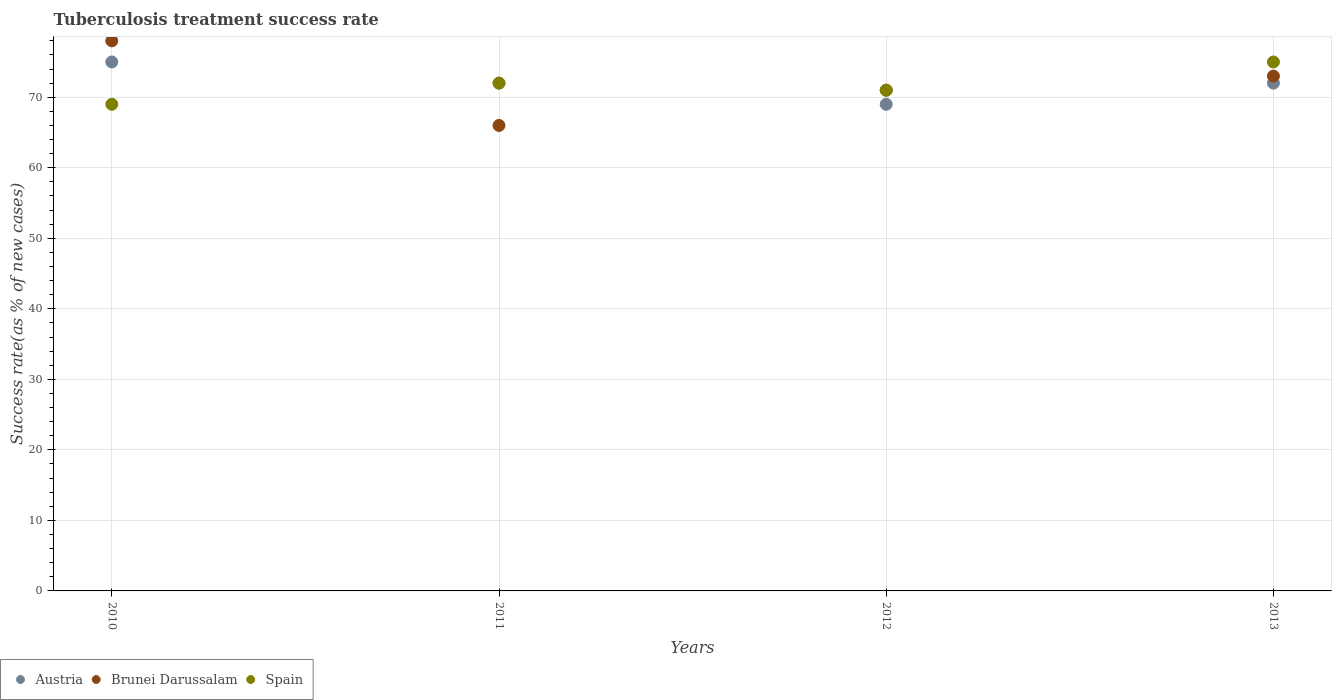How many different coloured dotlines are there?
Offer a very short reply. 3. Is the number of dotlines equal to the number of legend labels?
Provide a short and direct response. Yes. What is the tuberculosis treatment success rate in Spain in 2012?
Offer a terse response. 71. Across all years, what is the maximum tuberculosis treatment success rate in Brunei Darussalam?
Give a very brief answer. 78. Across all years, what is the minimum tuberculosis treatment success rate in Spain?
Offer a very short reply. 69. In which year was the tuberculosis treatment success rate in Brunei Darussalam minimum?
Provide a succinct answer. 2011. What is the total tuberculosis treatment success rate in Brunei Darussalam in the graph?
Provide a short and direct response. 288. What is the difference between the tuberculosis treatment success rate in Spain in 2010 and that in 2012?
Ensure brevity in your answer.  -2. What is the average tuberculosis treatment success rate in Brunei Darussalam per year?
Give a very brief answer. 72. In the year 2012, what is the difference between the tuberculosis treatment success rate in Brunei Darussalam and tuberculosis treatment success rate in Austria?
Offer a terse response. 2. In how many years, is the tuberculosis treatment success rate in Austria greater than 8 %?
Keep it short and to the point. 4. What is the ratio of the tuberculosis treatment success rate in Spain in 2010 to that in 2012?
Ensure brevity in your answer.  0.97. Is the tuberculosis treatment success rate in Spain in 2010 less than that in 2013?
Keep it short and to the point. Yes. Is the difference between the tuberculosis treatment success rate in Brunei Darussalam in 2011 and 2012 greater than the difference between the tuberculosis treatment success rate in Austria in 2011 and 2012?
Provide a succinct answer. No. What is the difference between the highest and the second highest tuberculosis treatment success rate in Austria?
Your response must be concise. 3. In how many years, is the tuberculosis treatment success rate in Austria greater than the average tuberculosis treatment success rate in Austria taken over all years?
Offer a terse response. 1. Is the tuberculosis treatment success rate in Spain strictly greater than the tuberculosis treatment success rate in Brunei Darussalam over the years?
Offer a very short reply. No. What is the difference between two consecutive major ticks on the Y-axis?
Your answer should be very brief. 10. Does the graph contain grids?
Make the answer very short. Yes. What is the title of the graph?
Your answer should be compact. Tuberculosis treatment success rate. Does "Bolivia" appear as one of the legend labels in the graph?
Your answer should be very brief. No. What is the label or title of the X-axis?
Your answer should be very brief. Years. What is the label or title of the Y-axis?
Provide a succinct answer. Success rate(as % of new cases). What is the Success rate(as % of new cases) in Brunei Darussalam in 2011?
Provide a succinct answer. 66. What is the Success rate(as % of new cases) of Austria in 2012?
Provide a short and direct response. 69. What is the Success rate(as % of new cases) of Brunei Darussalam in 2012?
Offer a very short reply. 71. What is the Success rate(as % of new cases) in Spain in 2012?
Offer a very short reply. 71. What is the Success rate(as % of new cases) in Austria in 2013?
Offer a terse response. 72. What is the Success rate(as % of new cases) of Brunei Darussalam in 2013?
Offer a very short reply. 73. What is the Success rate(as % of new cases) of Spain in 2013?
Keep it short and to the point. 75. Across all years, what is the maximum Success rate(as % of new cases) of Austria?
Keep it short and to the point. 75. Across all years, what is the maximum Success rate(as % of new cases) in Spain?
Your answer should be very brief. 75. Across all years, what is the minimum Success rate(as % of new cases) of Spain?
Your answer should be very brief. 69. What is the total Success rate(as % of new cases) of Austria in the graph?
Keep it short and to the point. 288. What is the total Success rate(as % of new cases) in Brunei Darussalam in the graph?
Your response must be concise. 288. What is the total Success rate(as % of new cases) in Spain in the graph?
Offer a very short reply. 287. What is the difference between the Success rate(as % of new cases) in Spain in 2010 and that in 2011?
Your response must be concise. -3. What is the difference between the Success rate(as % of new cases) of Brunei Darussalam in 2010 and that in 2012?
Ensure brevity in your answer.  7. What is the difference between the Success rate(as % of new cases) in Spain in 2010 and that in 2012?
Your response must be concise. -2. What is the difference between the Success rate(as % of new cases) in Brunei Darussalam in 2010 and that in 2013?
Your response must be concise. 5. What is the difference between the Success rate(as % of new cases) in Brunei Darussalam in 2011 and that in 2012?
Your answer should be very brief. -5. What is the difference between the Success rate(as % of new cases) in Brunei Darussalam in 2011 and that in 2013?
Offer a very short reply. -7. What is the difference between the Success rate(as % of new cases) in Austria in 2012 and that in 2013?
Make the answer very short. -3. What is the difference between the Success rate(as % of new cases) in Brunei Darussalam in 2012 and that in 2013?
Offer a very short reply. -2. What is the difference between the Success rate(as % of new cases) of Brunei Darussalam in 2010 and the Success rate(as % of new cases) of Spain in 2011?
Provide a short and direct response. 6. What is the difference between the Success rate(as % of new cases) in Austria in 2010 and the Success rate(as % of new cases) in Brunei Darussalam in 2012?
Your response must be concise. 4. What is the difference between the Success rate(as % of new cases) of Austria in 2010 and the Success rate(as % of new cases) of Spain in 2012?
Provide a short and direct response. 4. What is the difference between the Success rate(as % of new cases) of Brunei Darussalam in 2010 and the Success rate(as % of new cases) of Spain in 2012?
Your answer should be very brief. 7. What is the difference between the Success rate(as % of new cases) in Austria in 2010 and the Success rate(as % of new cases) in Brunei Darussalam in 2013?
Provide a short and direct response. 2. What is the difference between the Success rate(as % of new cases) in Austria in 2010 and the Success rate(as % of new cases) in Spain in 2013?
Offer a terse response. 0. What is the difference between the Success rate(as % of new cases) of Brunei Darussalam in 2010 and the Success rate(as % of new cases) of Spain in 2013?
Provide a succinct answer. 3. What is the difference between the Success rate(as % of new cases) of Austria in 2011 and the Success rate(as % of new cases) of Brunei Darussalam in 2012?
Provide a short and direct response. 1. What is the difference between the Success rate(as % of new cases) of Austria in 2011 and the Success rate(as % of new cases) of Spain in 2012?
Your answer should be very brief. 1. What is the difference between the Success rate(as % of new cases) of Brunei Darussalam in 2011 and the Success rate(as % of new cases) of Spain in 2013?
Provide a short and direct response. -9. What is the difference between the Success rate(as % of new cases) in Brunei Darussalam in 2012 and the Success rate(as % of new cases) in Spain in 2013?
Provide a short and direct response. -4. What is the average Success rate(as % of new cases) of Brunei Darussalam per year?
Your answer should be compact. 72. What is the average Success rate(as % of new cases) of Spain per year?
Your answer should be compact. 71.75. In the year 2010, what is the difference between the Success rate(as % of new cases) of Austria and Success rate(as % of new cases) of Spain?
Keep it short and to the point. 6. In the year 2010, what is the difference between the Success rate(as % of new cases) of Brunei Darussalam and Success rate(as % of new cases) of Spain?
Offer a very short reply. 9. In the year 2011, what is the difference between the Success rate(as % of new cases) in Austria and Success rate(as % of new cases) in Brunei Darussalam?
Offer a terse response. 6. In the year 2011, what is the difference between the Success rate(as % of new cases) in Austria and Success rate(as % of new cases) in Spain?
Offer a very short reply. 0. In the year 2011, what is the difference between the Success rate(as % of new cases) of Brunei Darussalam and Success rate(as % of new cases) of Spain?
Offer a terse response. -6. In the year 2012, what is the difference between the Success rate(as % of new cases) in Austria and Success rate(as % of new cases) in Spain?
Offer a very short reply. -2. In the year 2013, what is the difference between the Success rate(as % of new cases) of Brunei Darussalam and Success rate(as % of new cases) of Spain?
Give a very brief answer. -2. What is the ratio of the Success rate(as % of new cases) of Austria in 2010 to that in 2011?
Give a very brief answer. 1.04. What is the ratio of the Success rate(as % of new cases) in Brunei Darussalam in 2010 to that in 2011?
Keep it short and to the point. 1.18. What is the ratio of the Success rate(as % of new cases) of Spain in 2010 to that in 2011?
Keep it short and to the point. 0.96. What is the ratio of the Success rate(as % of new cases) in Austria in 2010 to that in 2012?
Your answer should be very brief. 1.09. What is the ratio of the Success rate(as % of new cases) of Brunei Darussalam in 2010 to that in 2012?
Give a very brief answer. 1.1. What is the ratio of the Success rate(as % of new cases) in Spain in 2010 to that in 2012?
Give a very brief answer. 0.97. What is the ratio of the Success rate(as % of new cases) of Austria in 2010 to that in 2013?
Provide a short and direct response. 1.04. What is the ratio of the Success rate(as % of new cases) of Brunei Darussalam in 2010 to that in 2013?
Provide a succinct answer. 1.07. What is the ratio of the Success rate(as % of new cases) in Spain in 2010 to that in 2013?
Provide a succinct answer. 0.92. What is the ratio of the Success rate(as % of new cases) of Austria in 2011 to that in 2012?
Your response must be concise. 1.04. What is the ratio of the Success rate(as % of new cases) of Brunei Darussalam in 2011 to that in 2012?
Give a very brief answer. 0.93. What is the ratio of the Success rate(as % of new cases) in Spain in 2011 to that in 2012?
Your response must be concise. 1.01. What is the ratio of the Success rate(as % of new cases) in Brunei Darussalam in 2011 to that in 2013?
Keep it short and to the point. 0.9. What is the ratio of the Success rate(as % of new cases) in Spain in 2011 to that in 2013?
Offer a terse response. 0.96. What is the ratio of the Success rate(as % of new cases) in Brunei Darussalam in 2012 to that in 2013?
Give a very brief answer. 0.97. What is the ratio of the Success rate(as % of new cases) in Spain in 2012 to that in 2013?
Make the answer very short. 0.95. What is the difference between the highest and the second highest Success rate(as % of new cases) of Austria?
Give a very brief answer. 3. What is the difference between the highest and the second highest Success rate(as % of new cases) of Spain?
Your answer should be compact. 3. What is the difference between the highest and the lowest Success rate(as % of new cases) in Austria?
Provide a short and direct response. 6. 